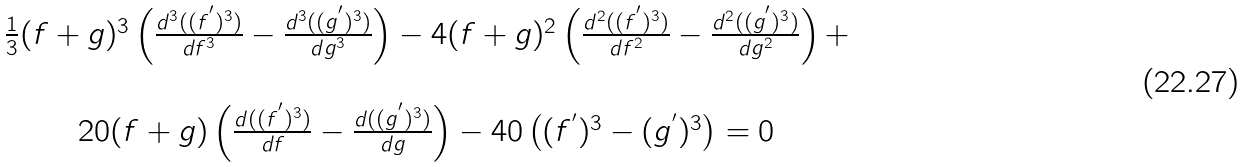Convert formula to latex. <formula><loc_0><loc_0><loc_500><loc_500>\begin{array} { c } \frac { 1 } { 3 } ( f + g ) ^ { 3 } \left ( \frac { d ^ { 3 } ( ( f ^ { ^ { \prime } } ) ^ { 3 } ) } { d f ^ { 3 } } - \frac { d ^ { 3 } ( ( g ^ { ^ { \prime } } ) ^ { 3 } ) } { d g ^ { 3 } } \right ) - 4 ( f + g ) ^ { 2 } \left ( \frac { d ^ { 2 } ( ( f ^ { ^ { \prime } } ) ^ { 3 } ) } { d f ^ { 2 } } - \frac { d ^ { 2 } ( ( g ^ { ^ { \prime } } ) ^ { 3 } ) } { d g ^ { 2 } } \right ) + \\ \ \\ 2 0 ( f + g ) \left ( \frac { d ( ( f ^ { ^ { \prime } } ) ^ { 3 } ) } { d f } - \frac { d ( ( g ^ { ^ { \prime } } ) ^ { 3 } ) } { d g } \right ) - 4 0 \left ( ( f ^ { ^ { \prime } } ) ^ { 3 } - ( g ^ { ^ { \prime } } ) ^ { 3 } \right ) = 0 \end{array}</formula> 